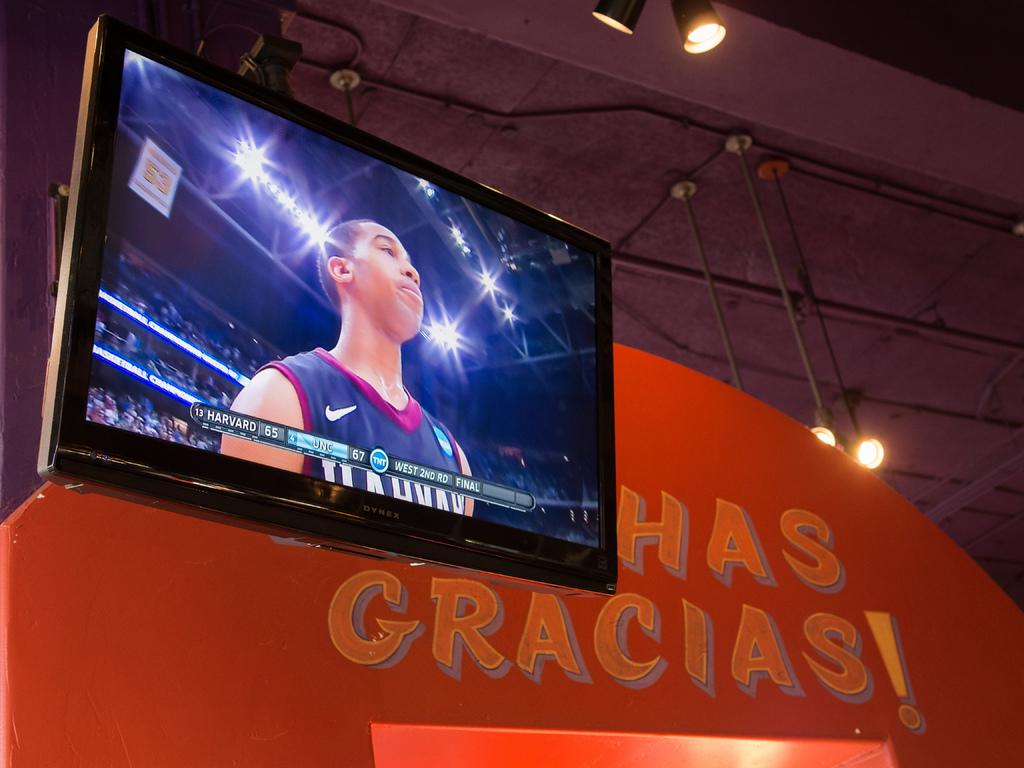Which team is leading?
Provide a short and direct response. Unc. What basketball teams are playing each other?
Offer a terse response. Harvard and unc. 